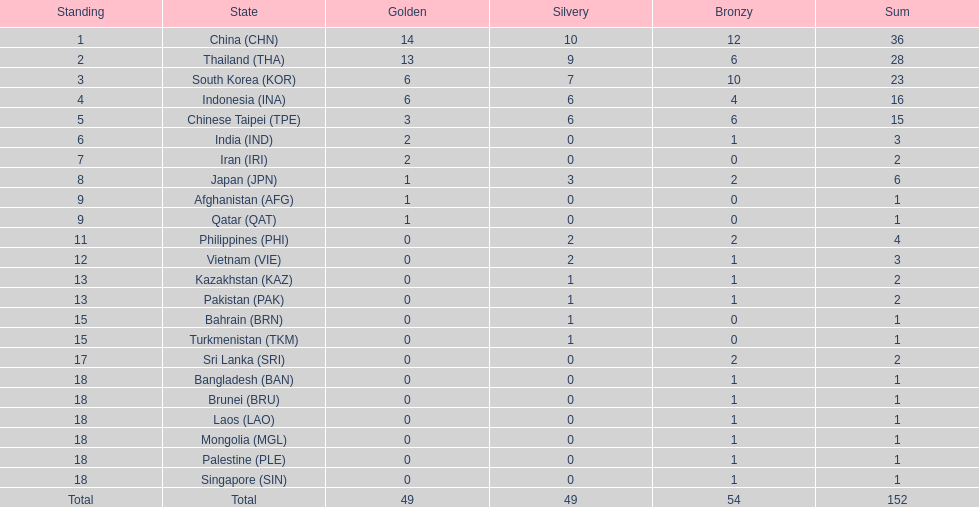What is the total number of nations that participated in the beach games of 2012? 23. 